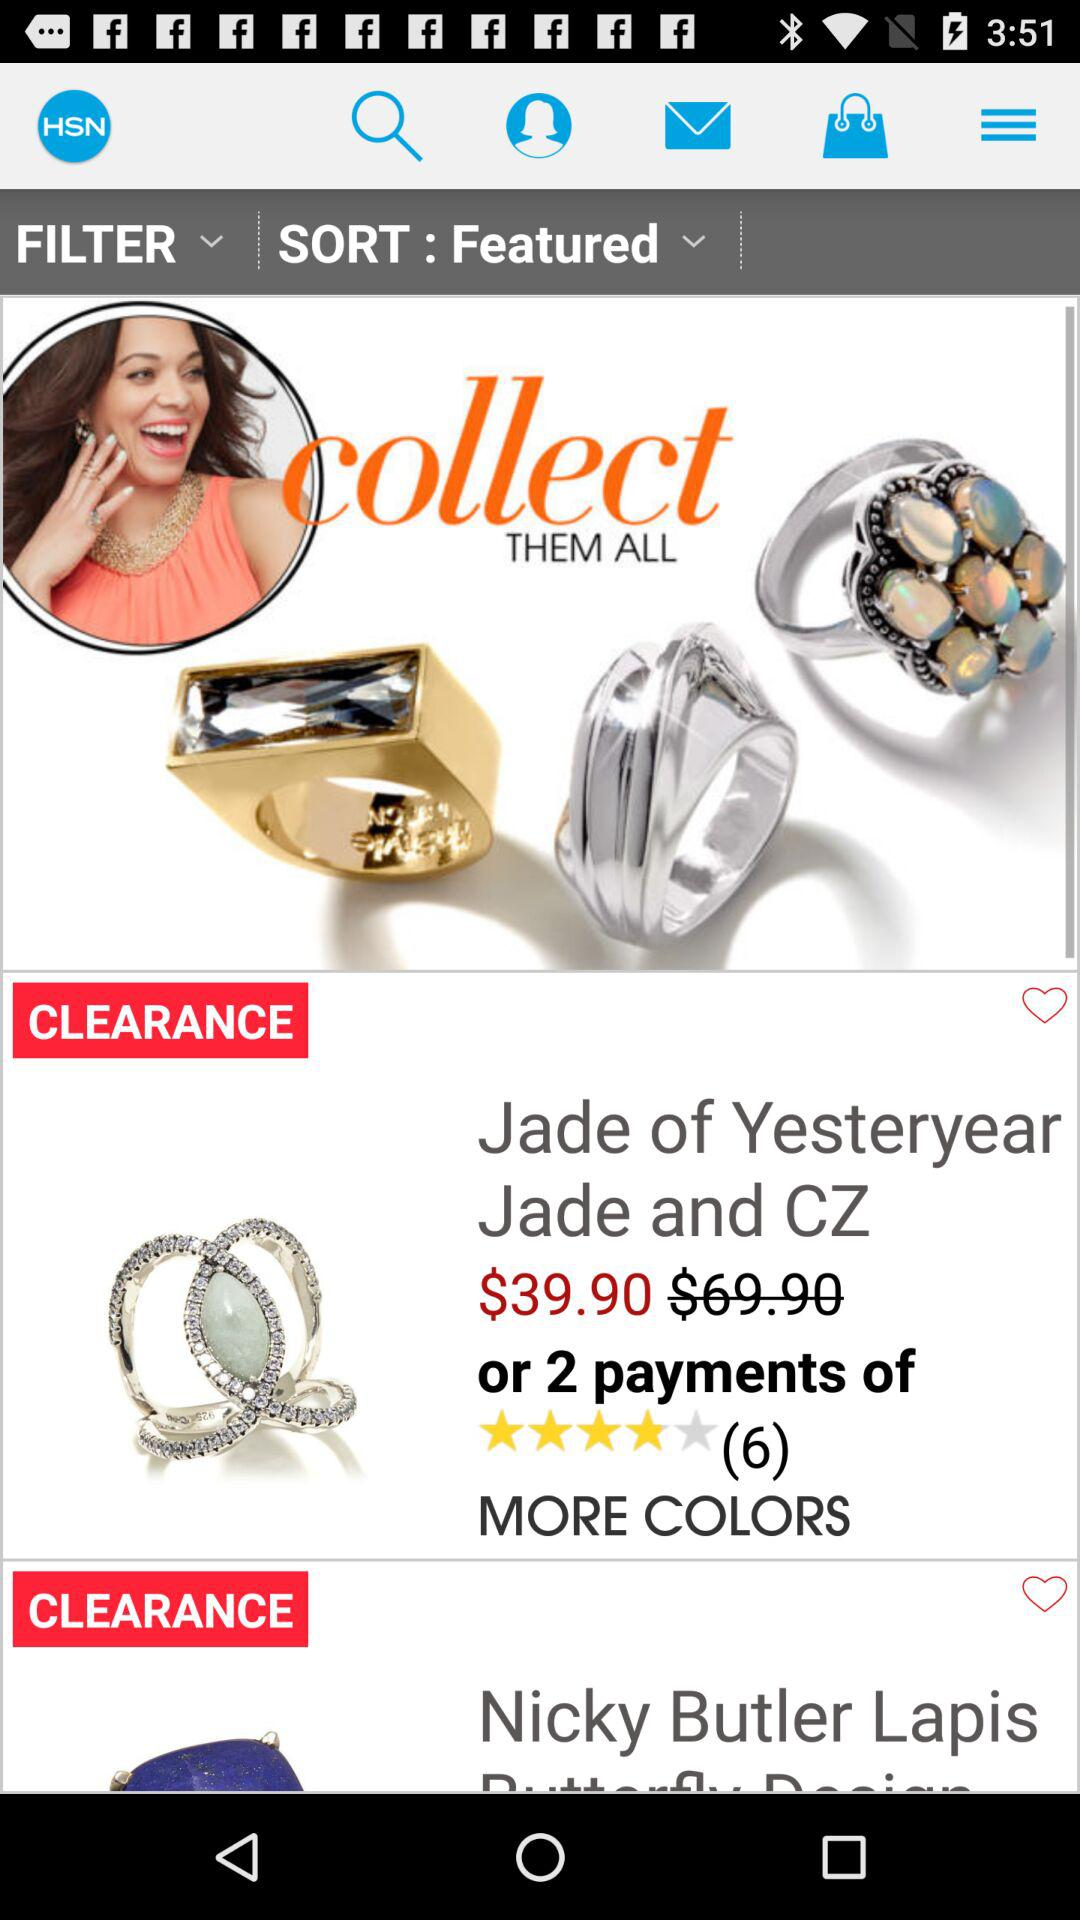What is the rating of "Jade of Yesteryear Jade and CZ"? The rating is 4 stars. 